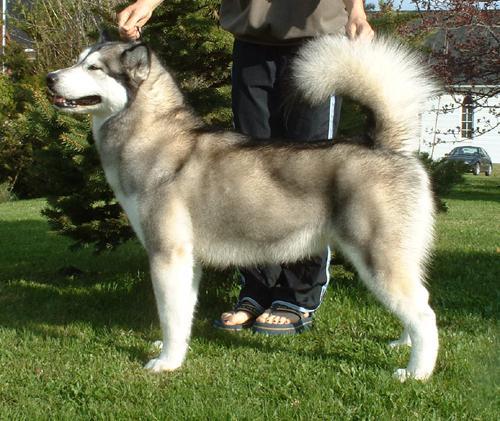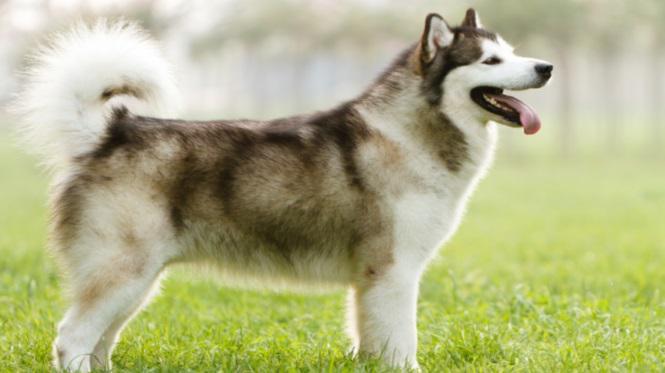The first image is the image on the left, the second image is the image on the right. Examine the images to the left and right. Is the description "The image on the right shows a left-facing dog standing in front of its owner." accurate? Answer yes or no. No. The first image is the image on the left, the second image is the image on the right. Analyze the images presented: Is the assertion "All dogs are huskies with dark-and-white fur who are standing in profile, and the dogs on the left and right do not face the same [left or right] direction." valid? Answer yes or no. Yes. 